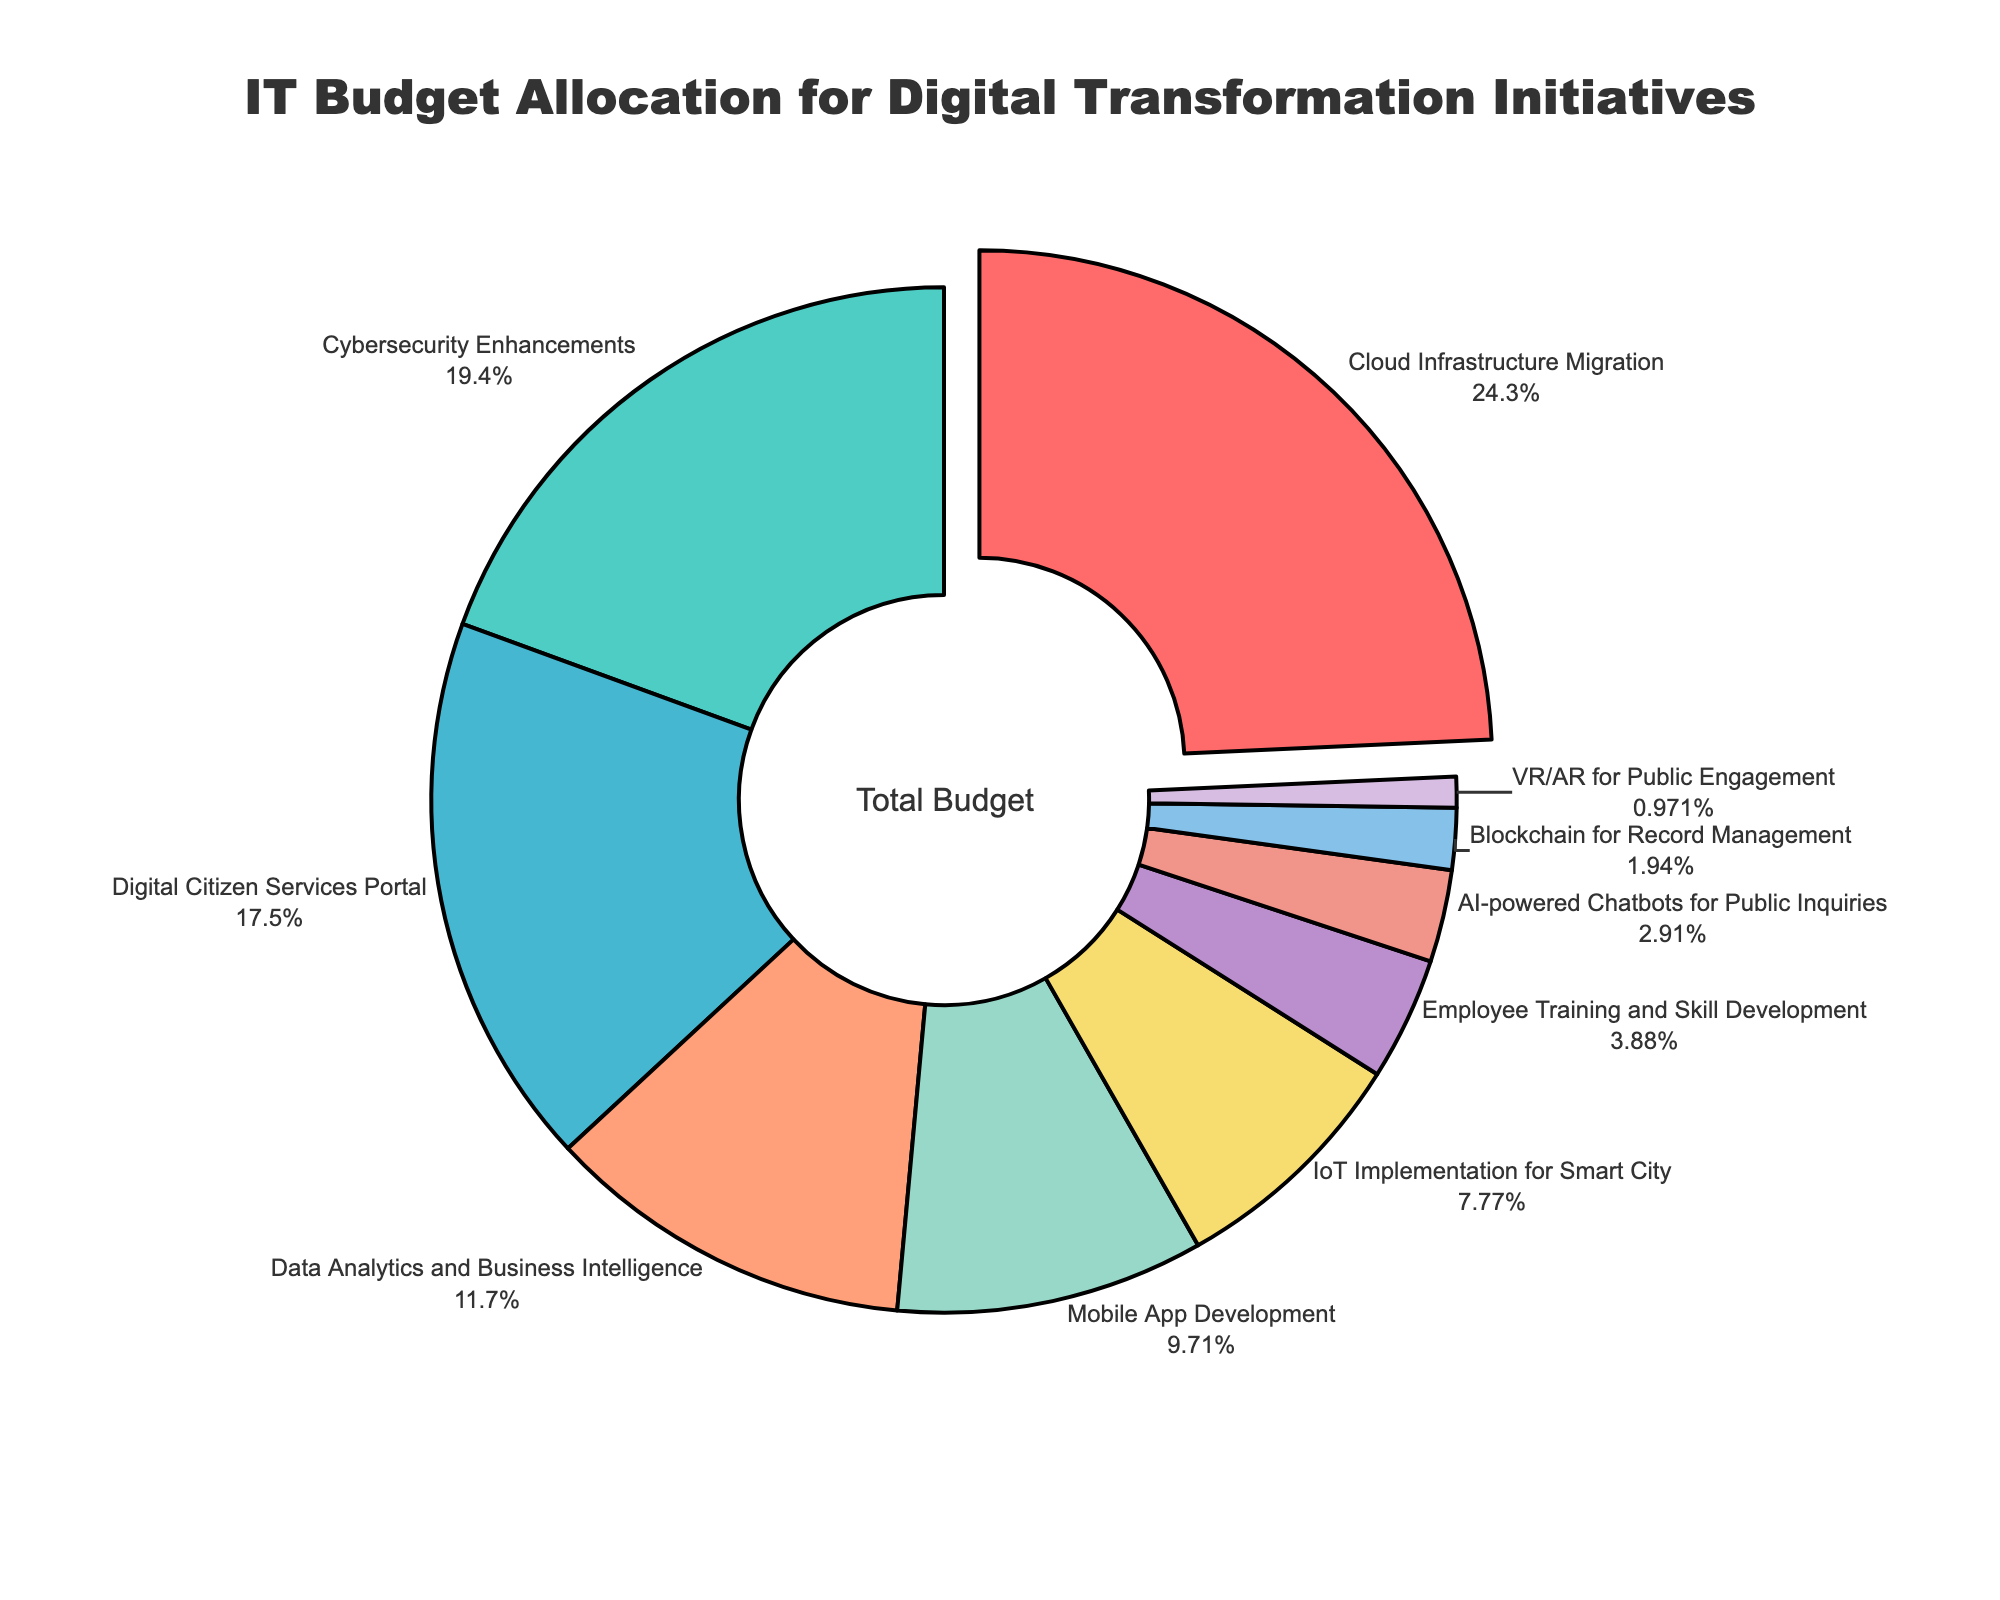What is the digital transformation initiative with the largest budget allocation? Look at the pie chart to find the initiative with the largest segment. It is also pulled out slightly for emphasis.
Answer: Cloud Infrastructure Migration Which initiative has a lower budget allocation: IoT Implementation for Smart City or Data Analytics and Business Intelligence? Compare the segments labeled "IoT Implementation for Smart City" and "Data Analytics and Business Intelligence". The former has a smaller segment.
Answer: IoT Implementation for Smart City What is the combined budget percentage allocated to Cybersecurity Enhancements and Mobile App Development? Find the budget percentages for "Cybersecurity Enhancements" and "Mobile App Development", and add them together (20% + 10%).
Answer: 30% What is the smallest budget percentage among all the initiatives? Which initiative is it allocated to? Identify the smallest segment in the pie chart and read the corresponding label.
Answer: 1%, VR/AR for Public Engagement Compare the budget allocation of Digital Citizen Services Portal to AI-powered Chatbots for Public Inquiries. By how much is the former greater? Find the budget percentages for "Digital Citizen Services Portal" and "AI-powered Chatbots for Public Inquiries" and subtract the smaller from the larger (18% - 3%).
Answer: 15% How many initiatives have been allocated a budget percentage of less than 10%? Count the segments with budget percentages under 10%. There are five such segments.
Answer: 5 Which initiatives are represented by the yellow and purple segments, and what are their respective budget percentages? Match the color descriptions to the segments in the pie chart. The yellow segment represents IoT Implementation for Smart City (8%), and the purple segment represents Blockchain for Record Management (2%).
Answer: IoT Implementation for Smart City (8%), Blockchain for Record Management (2%) What is the total budget percentage allocated to initiatives related to direct public engagement (Digital Citizen Services Portal, AI-powered Chatbots for Public Inquiries, and VR/AR for Public Engagement)? Add the budget percentages for "Digital Citizen Services Portal" (18%), "AI-powered Chatbots for Public Inquiries" (3%), and "VR/AR for Public Engagement" (1%).
Answer: 22% Which initiative has the closest budget percentage to the average budget percentage for all initiatives? Calculate the average budget percentage by summing all percentages and dividing by the number of initiatives (10). The average is 10.3%. Compare this to the budget percentages in the chart; Mobile App Development (10%) is closest.
Answer: Mobile App Development What is the difference in budget percentage between the initiatives focusing on cybersecurity (Cybersecurity Enhancements) and those focusing on employee training (Employee Training and Skill Development)? Subtract the budget percentage for "Employee Training and Skill Development" from "Cybersecurity Enhancements" (20% - 4%).
Answer: 16% 